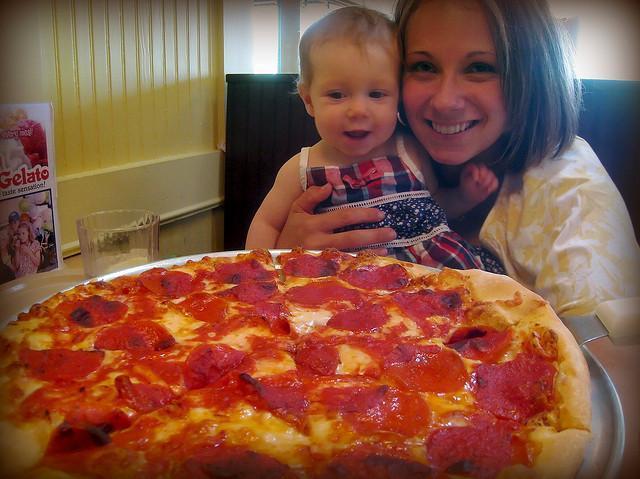How many stove knobs are visible?
Give a very brief answer. 0. How many pizza types are there?
Give a very brief answer. 1. How many people can you see?
Give a very brief answer. 2. How many cats are there?
Give a very brief answer. 0. 